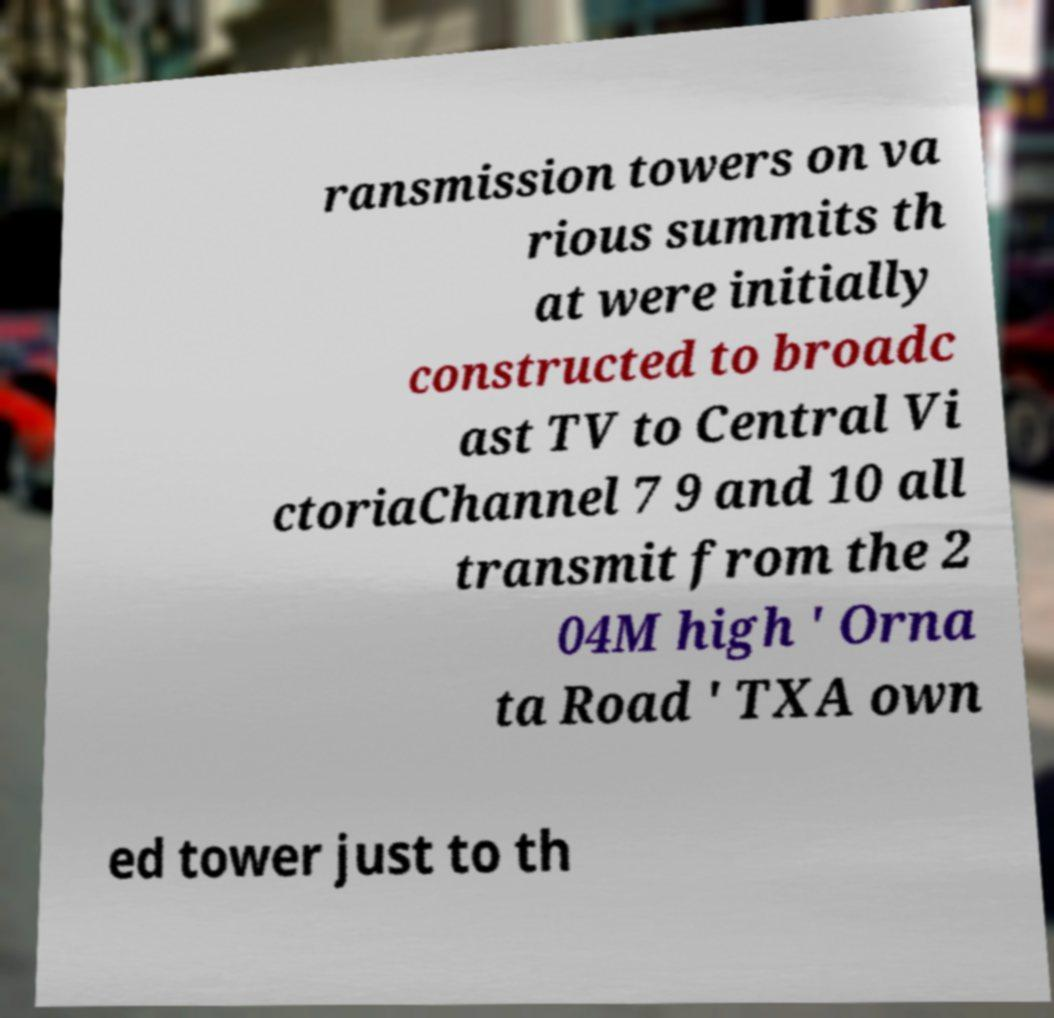I need the written content from this picture converted into text. Can you do that? ransmission towers on va rious summits th at were initially constructed to broadc ast TV to Central Vi ctoriaChannel 7 9 and 10 all transmit from the 2 04M high ' Orna ta Road ' TXA own ed tower just to th 